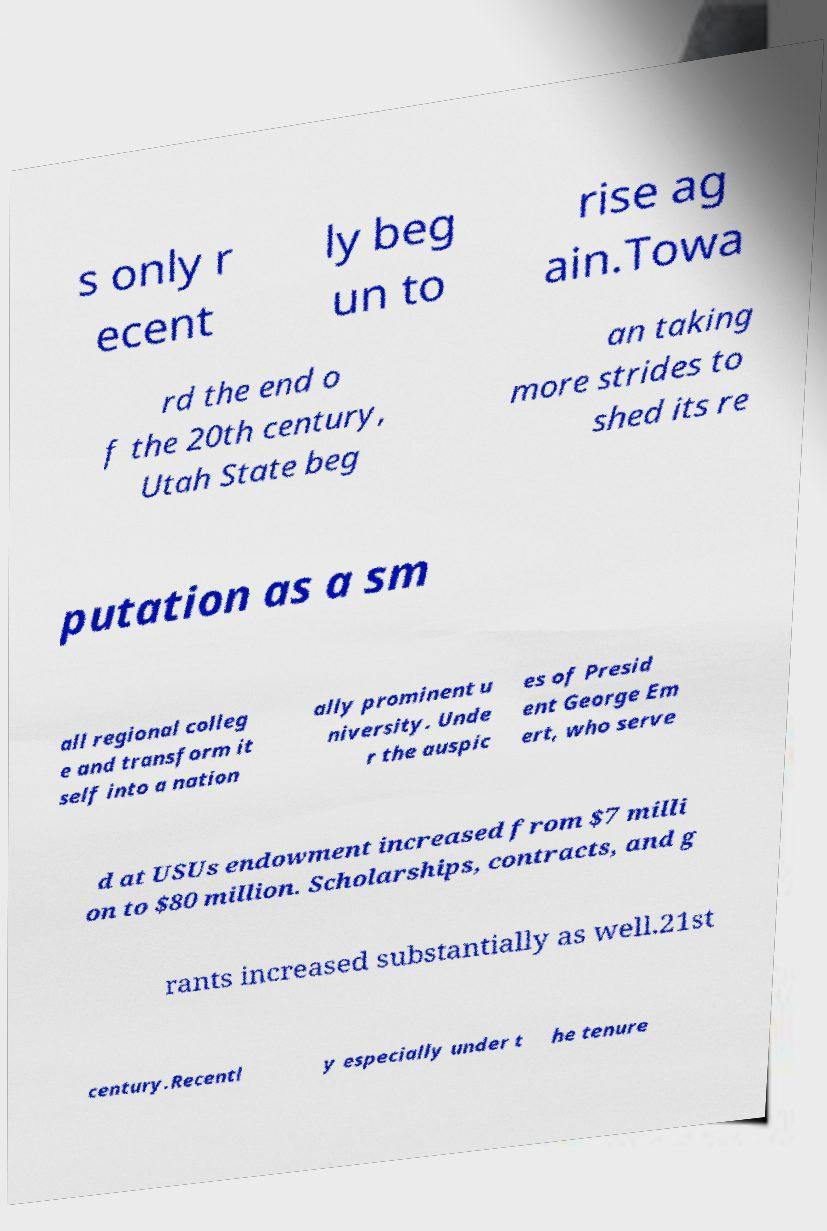I need the written content from this picture converted into text. Can you do that? s only r ecent ly beg un to rise ag ain.Towa rd the end o f the 20th century, Utah State beg an taking more strides to shed its re putation as a sm all regional colleg e and transform it self into a nation ally prominent u niversity. Unde r the auspic es of Presid ent George Em ert, who serve d at USUs endowment increased from $7 milli on to $80 million. Scholarships, contracts, and g rants increased substantially as well.21st century.Recentl y especially under t he tenure 